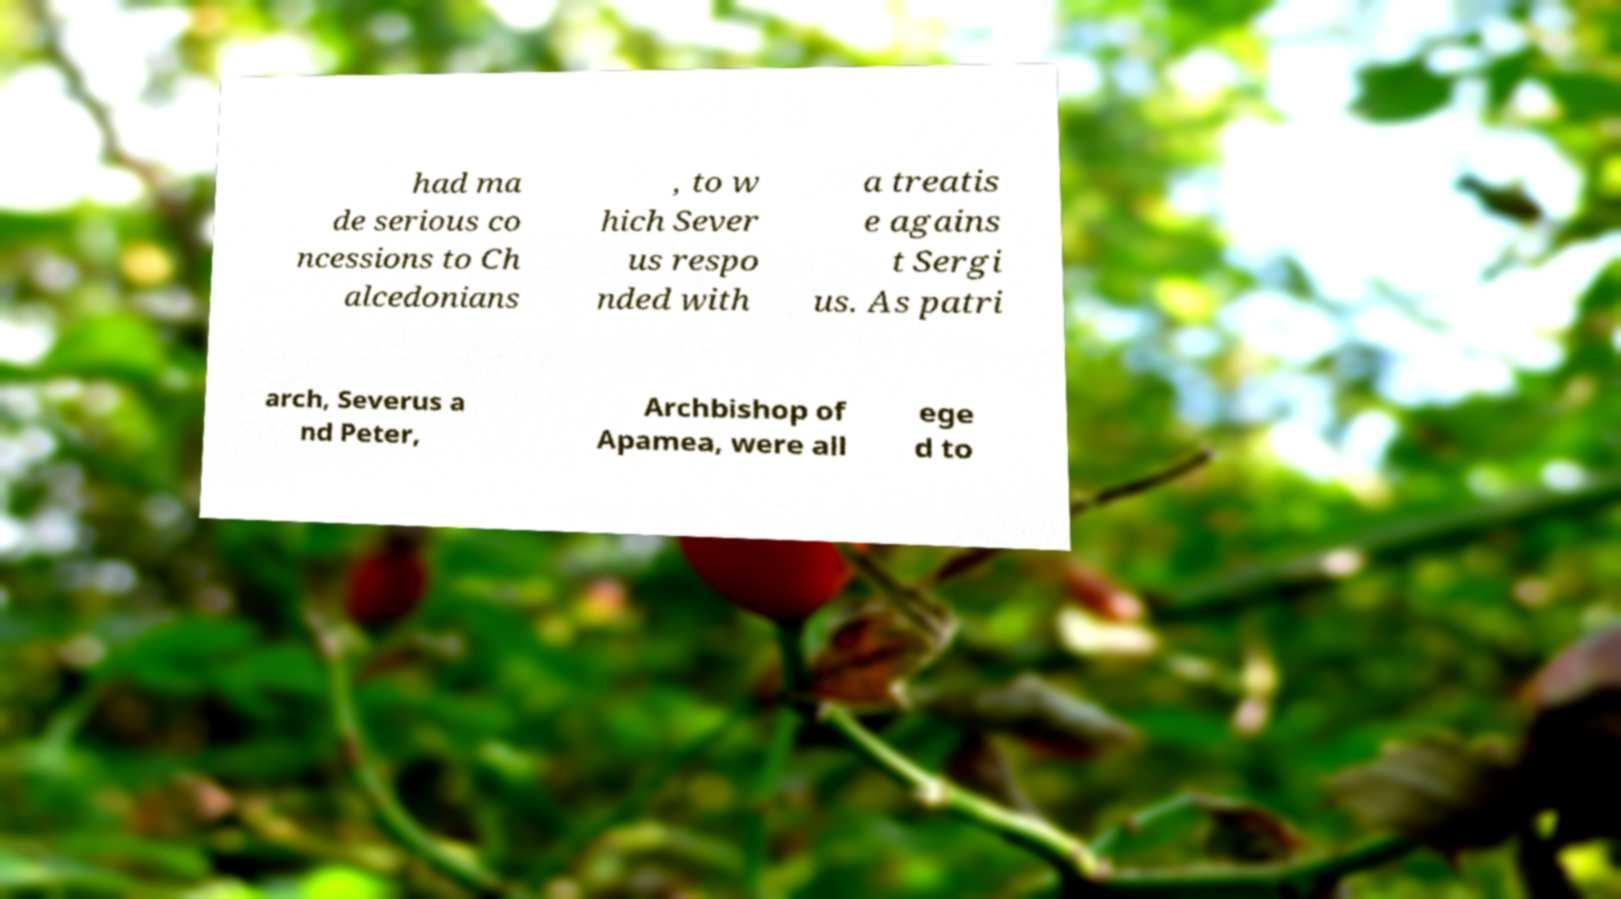Can you accurately transcribe the text from the provided image for me? had ma de serious co ncessions to Ch alcedonians , to w hich Sever us respo nded with a treatis e agains t Sergi us. As patri arch, Severus a nd Peter, Archbishop of Apamea, were all ege d to 